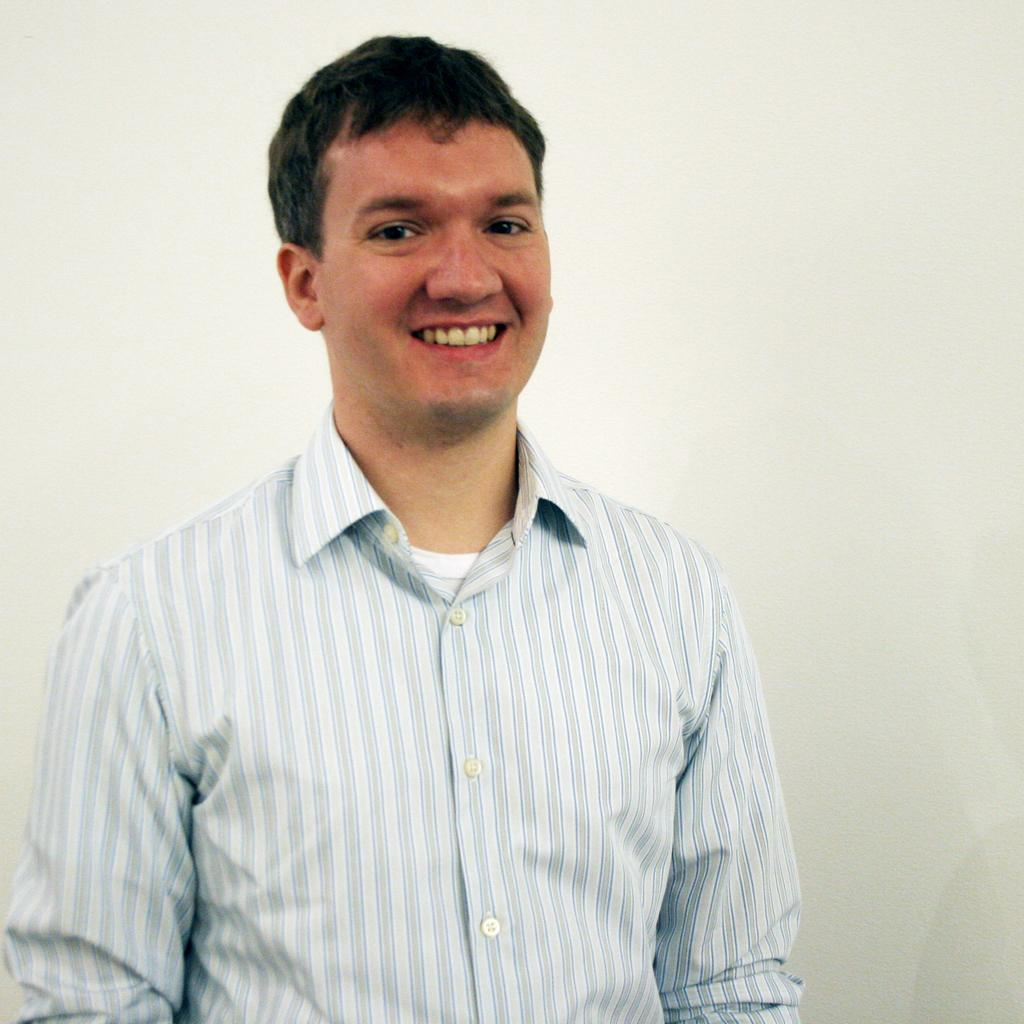What is present in the image? There is a person in the image. How is the person's facial expression? The person has a smile on their face. What disease is the person suffering from in the image? There is no indication of any disease in the image; the person has a smile on their face. 